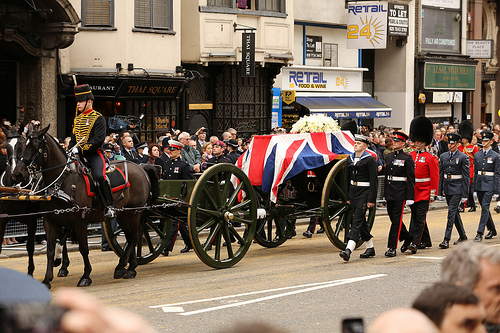What vehicle is shown in the photo? The vehicle shown in the photo is a wagon. 